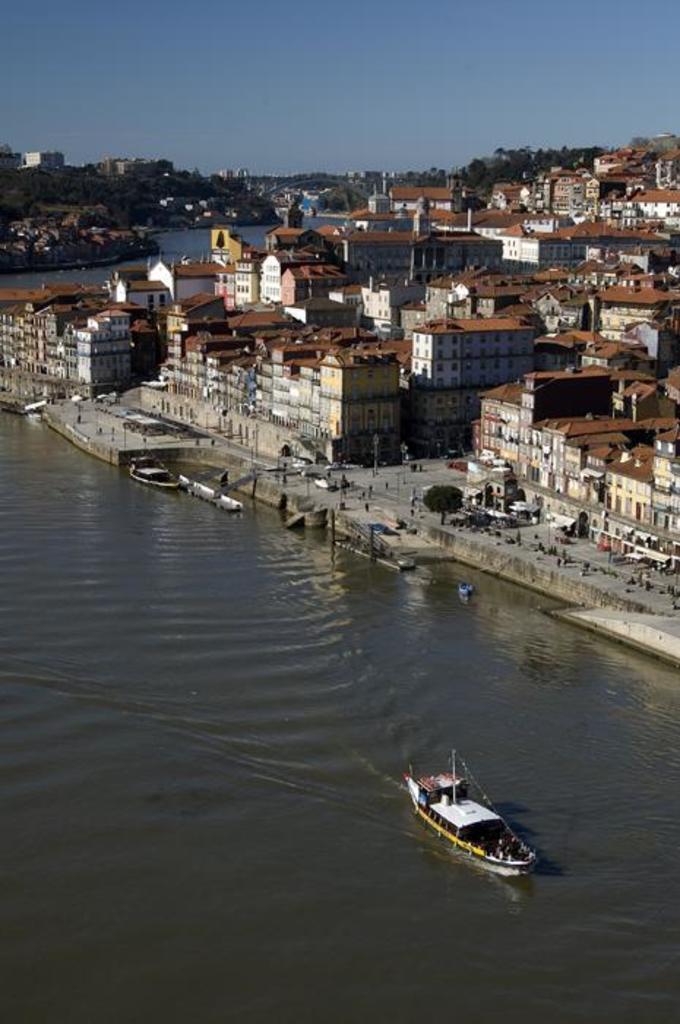In one or two sentences, can you explain what this image depicts? IN this image we can see some buildings, boats, poles, trees, also we can see the river, and the sky. 